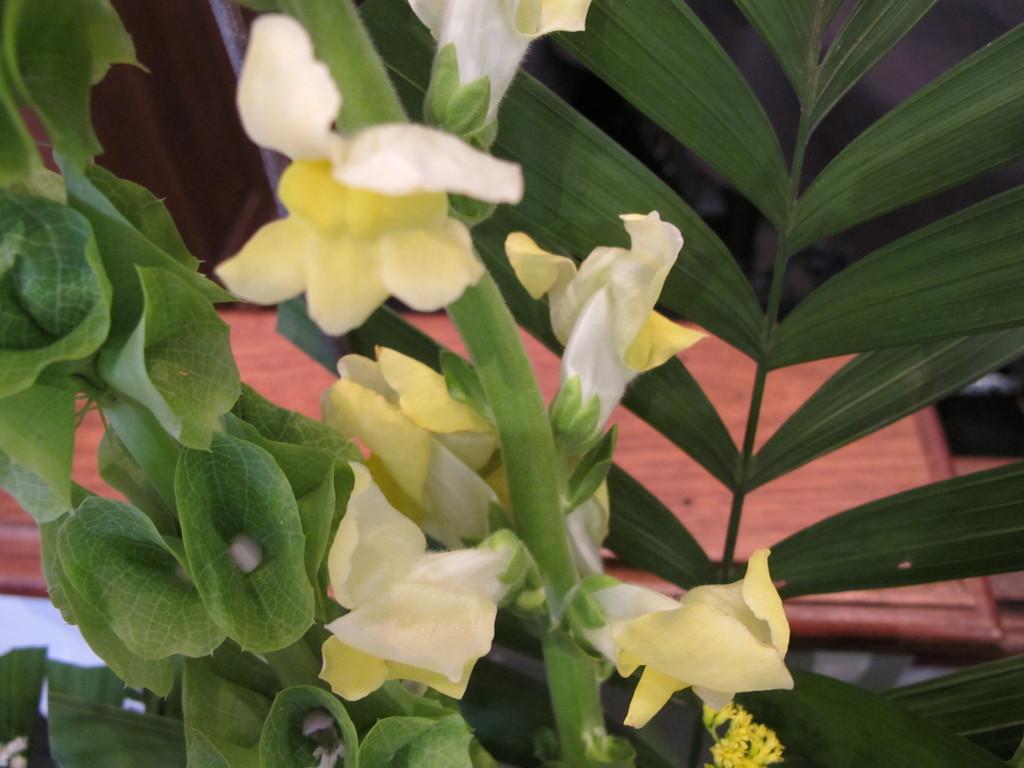Please provide a concise description of this image. In this picture I can see there are flowers and green leaves. 